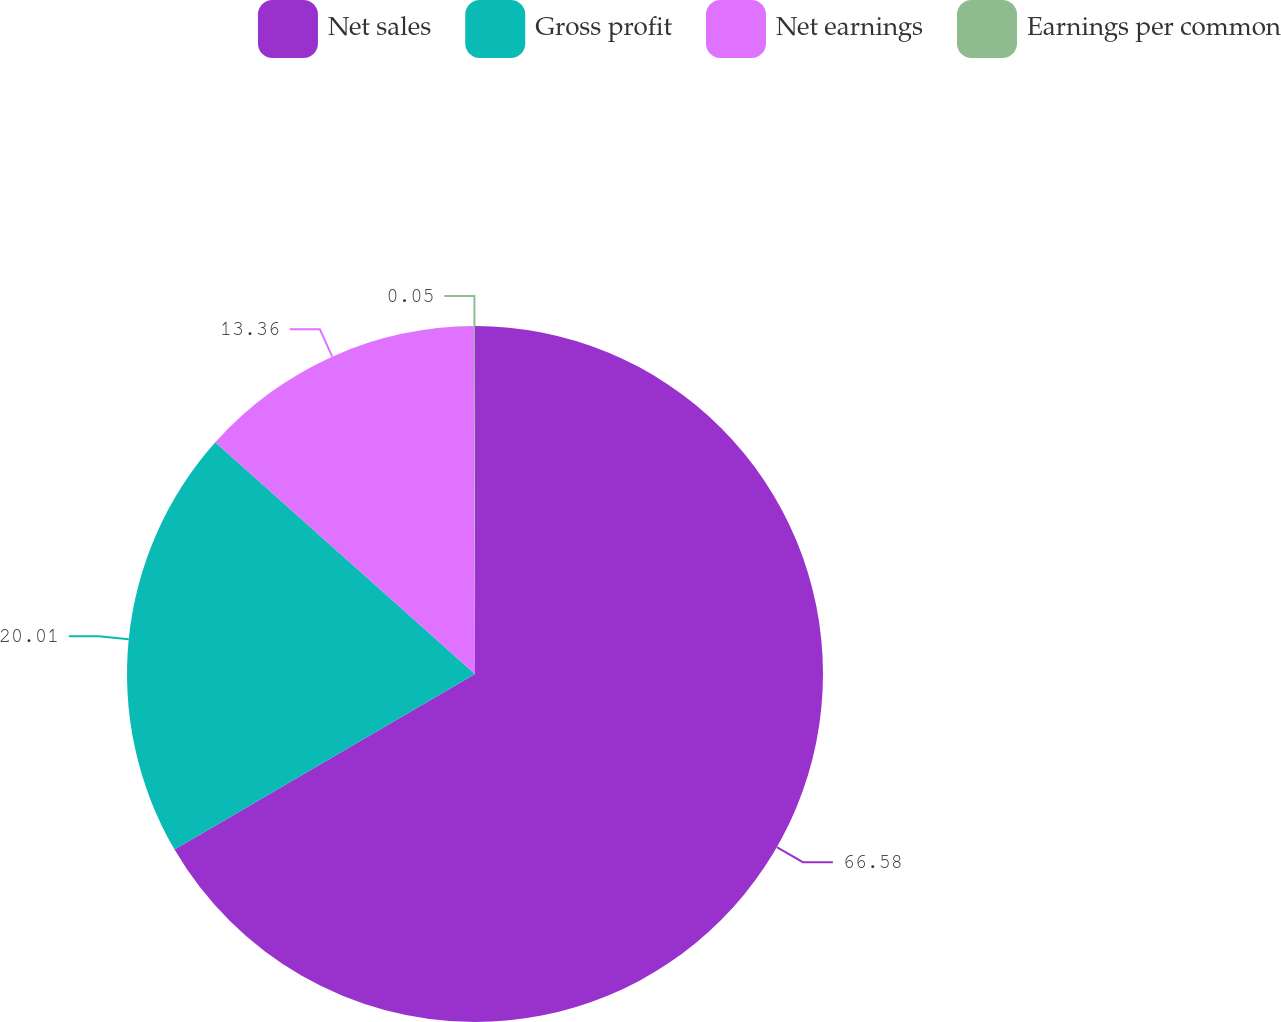Convert chart. <chart><loc_0><loc_0><loc_500><loc_500><pie_chart><fcel>Net sales<fcel>Gross profit<fcel>Net earnings<fcel>Earnings per common<nl><fcel>66.59%<fcel>20.01%<fcel>13.36%<fcel>0.05%<nl></chart> 